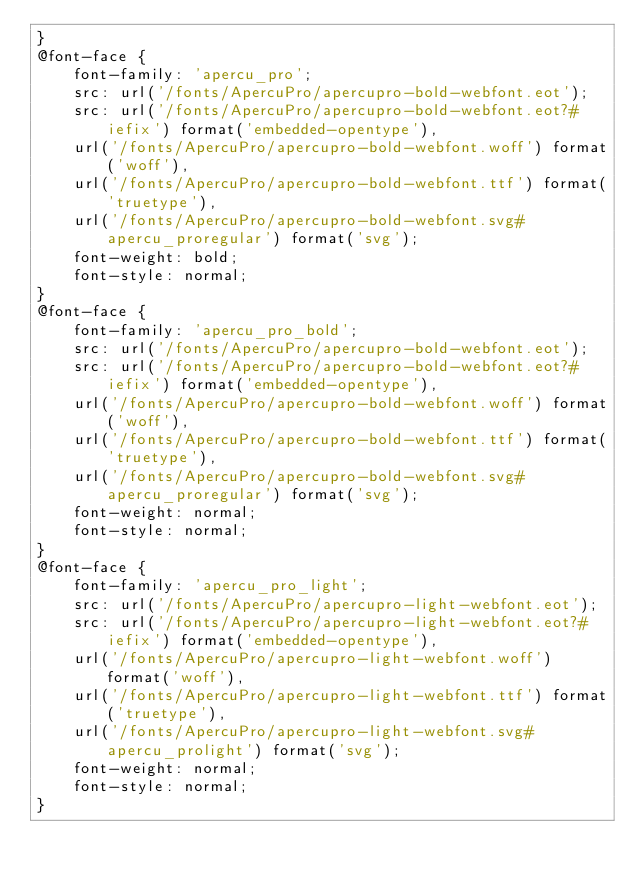<code> <loc_0><loc_0><loc_500><loc_500><_CSS_>}
@font-face {
    font-family: 'apercu_pro';
    src: url('/fonts/ApercuPro/apercupro-bold-webfont.eot');
    src: url('/fonts/ApercuPro/apercupro-bold-webfont.eot?#iefix') format('embedded-opentype'),
    url('/fonts/ApercuPro/apercupro-bold-webfont.woff') format('woff'),
    url('/fonts/ApercuPro/apercupro-bold-webfont.ttf') format('truetype'),
    url('/fonts/ApercuPro/apercupro-bold-webfont.svg#apercu_proregular') format('svg');
    font-weight: bold;
    font-style: normal;
}
@font-face {
    font-family: 'apercu_pro_bold';
    src: url('/fonts/ApercuPro/apercupro-bold-webfont.eot');
    src: url('/fonts/ApercuPro/apercupro-bold-webfont.eot?#iefix') format('embedded-opentype'),
    url('/fonts/ApercuPro/apercupro-bold-webfont.woff') format('woff'),
    url('/fonts/ApercuPro/apercupro-bold-webfont.ttf') format('truetype'),
    url('/fonts/ApercuPro/apercupro-bold-webfont.svg#apercu_proregular') format('svg');
    font-weight: normal;
    font-style: normal;
}
@font-face {
    font-family: 'apercu_pro_light';
    src: url('/fonts/ApercuPro/apercupro-light-webfont.eot');
    src: url('/fonts/ApercuPro/apercupro-light-webfont.eot?#iefix') format('embedded-opentype'),
    url('/fonts/ApercuPro/apercupro-light-webfont.woff') format('woff'),
    url('/fonts/ApercuPro/apercupro-light-webfont.ttf') format('truetype'),
    url('/fonts/ApercuPro/apercupro-light-webfont.svg#apercu_prolight') format('svg');
    font-weight: normal;
    font-style: normal;
}</code> 